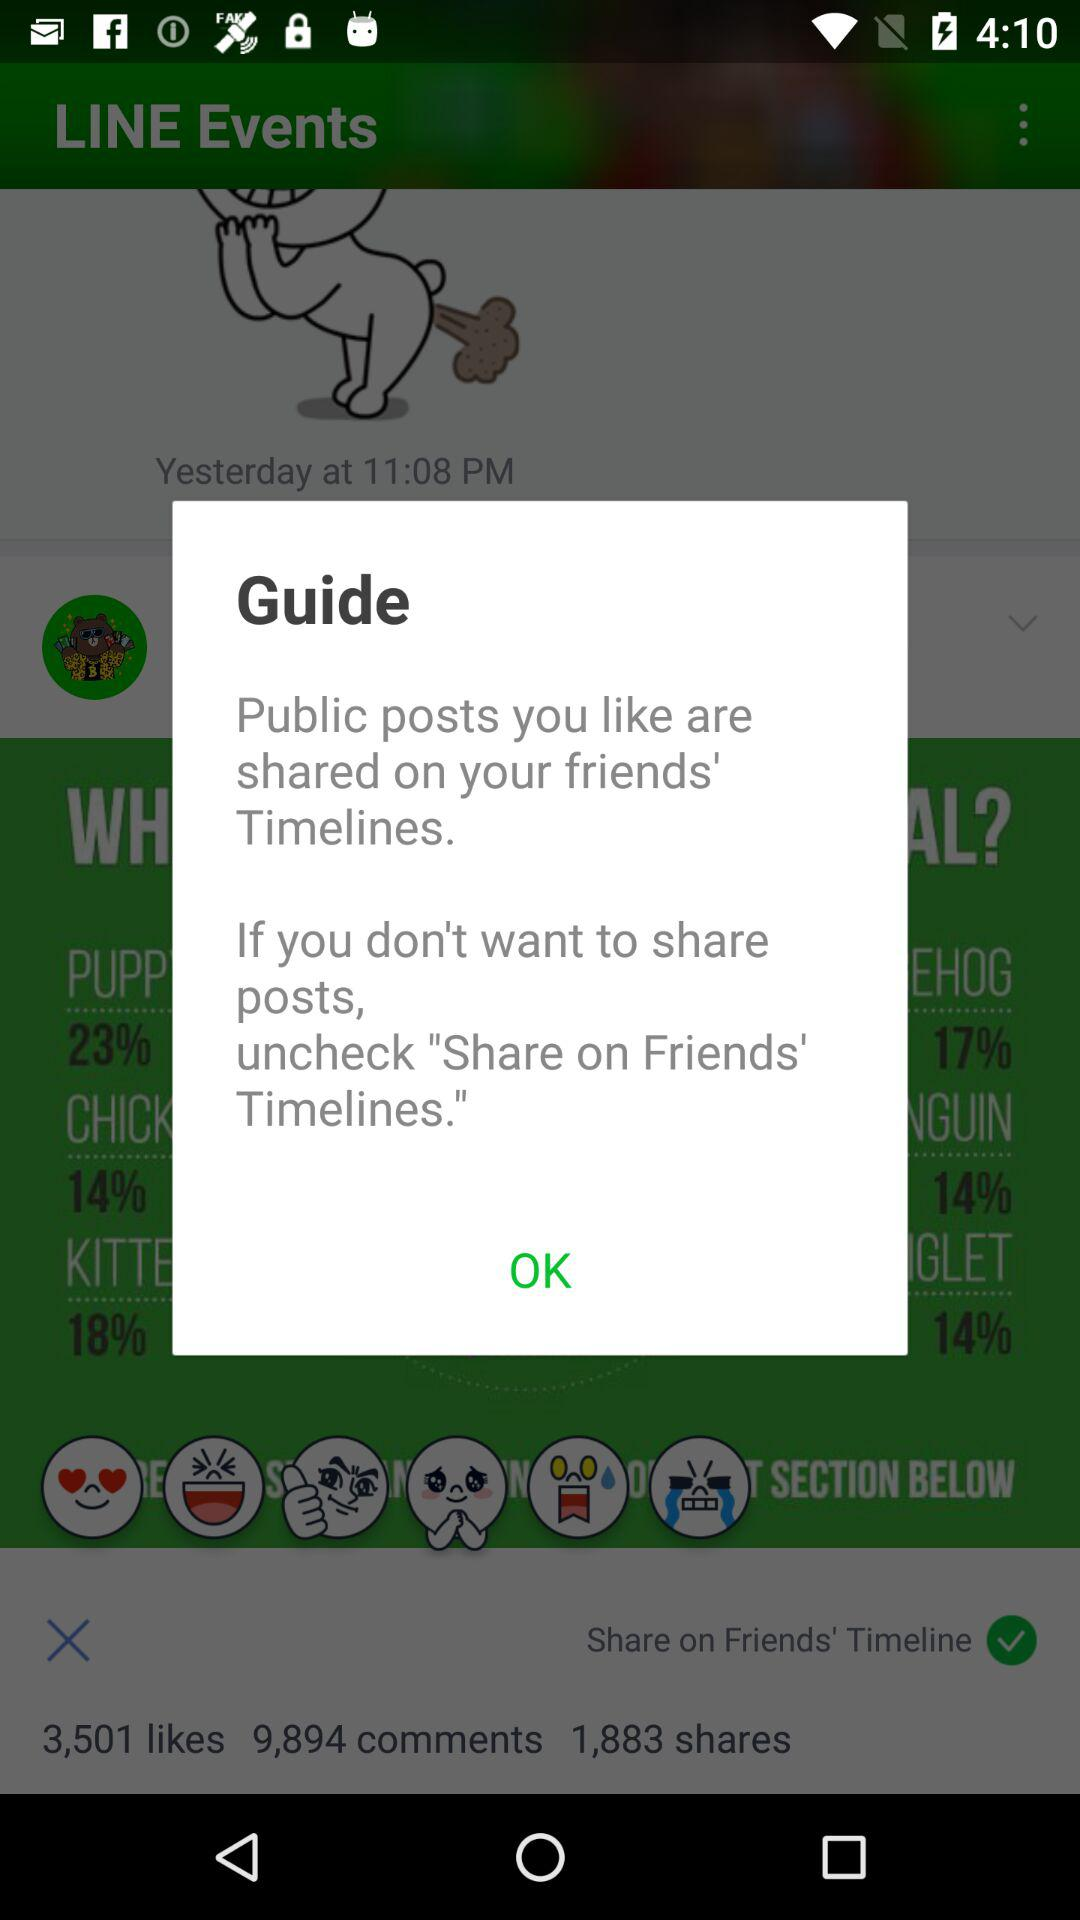How many comments are there? There are 9,894 comments. 